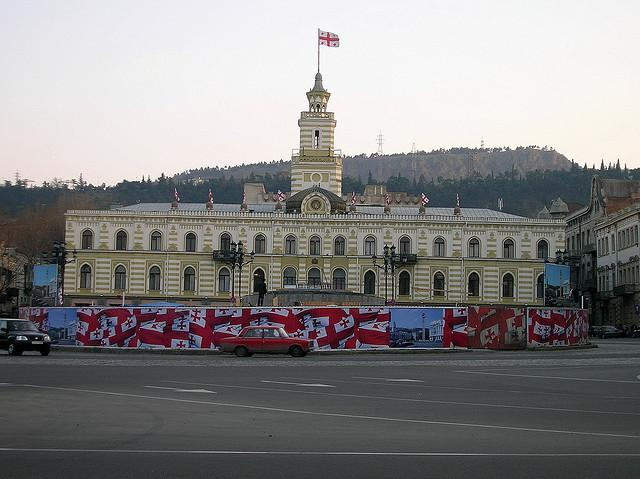This country has what type of government?

Choices:
A) republic
B) monarchy
C) anarchy
D) dictatorship republic 